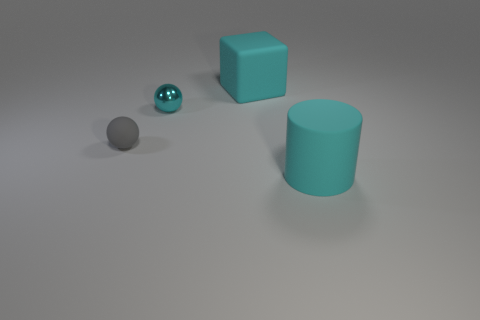Add 1 matte things. How many objects exist? 5 Subtract all cyan spheres. How many spheres are left? 1 Subtract all blocks. How many objects are left? 3 Subtract 1 spheres. How many spheres are left? 1 Subtract all green cubes. How many cyan balls are left? 1 Subtract 1 cyan cubes. How many objects are left? 3 Subtract all blue cylinders. Subtract all purple balls. How many cylinders are left? 1 Subtract all big cyan rubber cubes. Subtract all big cyan cylinders. How many objects are left? 2 Add 3 small cyan metal objects. How many small cyan metal objects are left? 4 Add 4 tiny gray matte balls. How many tiny gray matte balls exist? 5 